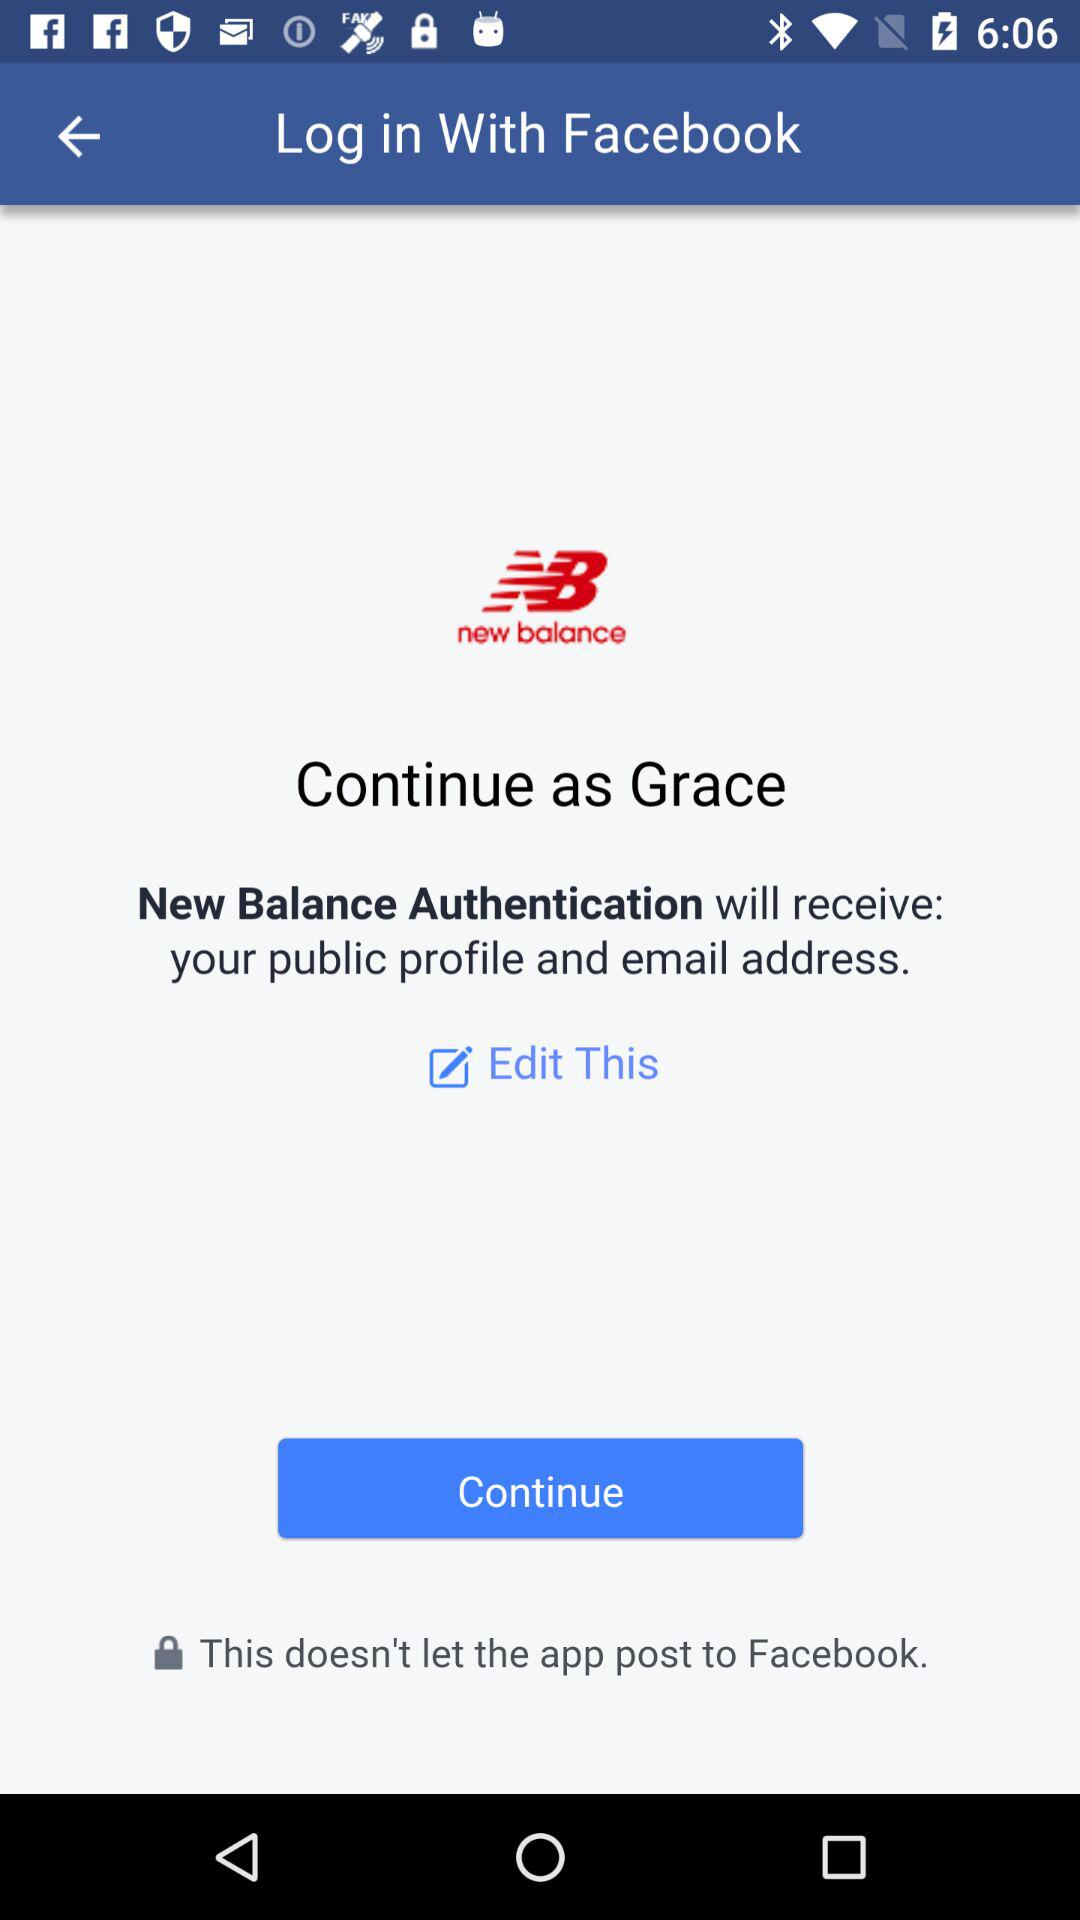What application is asking for permission? The application that is asking for permission is "New Balance Authentication". 